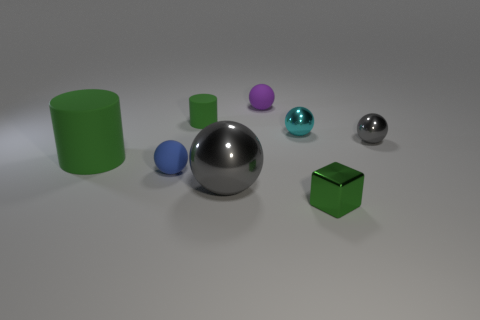What number of other objects are the same size as the purple rubber ball?
Your answer should be compact. 5. Are the tiny ball that is in front of the tiny gray metal ball and the big object that is left of the small blue rubber thing made of the same material?
Your answer should be very brief. Yes. There is a tiny gray metallic thing; how many large matte things are to the right of it?
Keep it short and to the point. 0. How many green objects are either large metallic objects or small rubber cylinders?
Make the answer very short. 1. What material is the purple thing that is the same size as the cyan object?
Your answer should be compact. Rubber. What is the shape of the tiny object that is both in front of the tiny gray shiny object and on the left side of the cyan thing?
Your response must be concise. Sphere. The shiny block that is the same size as the purple rubber thing is what color?
Provide a succinct answer. Green. There is a rubber ball that is to the right of the tiny rubber cylinder; does it have the same size as the rubber cylinder to the left of the tiny blue rubber thing?
Keep it short and to the point. No. What size is the green object in front of the green rubber cylinder in front of the small green matte object that is behind the metallic block?
Make the answer very short. Small. The small green object that is behind the gray object to the left of the purple object is what shape?
Make the answer very short. Cylinder. 